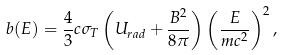<formula> <loc_0><loc_0><loc_500><loc_500>b ( E ) = \frac { 4 } { 3 } c \sigma _ { T } \left ( U _ { r a d } + \frac { B ^ { 2 } } { 8 \pi } \right ) \left ( \frac { E } { m c ^ { 2 } } \right ) ^ { 2 } ,</formula> 